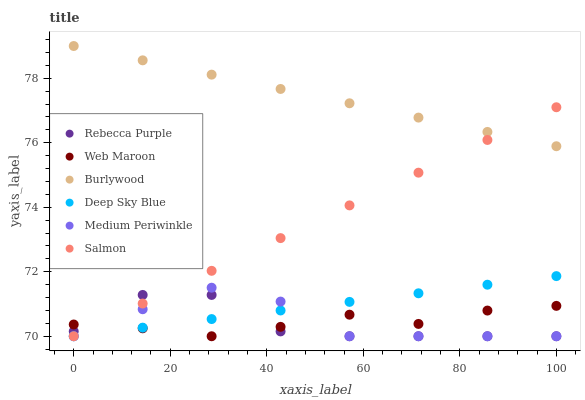Does Rebecca Purple have the minimum area under the curve?
Answer yes or no. Yes. Does Burlywood have the maximum area under the curve?
Answer yes or no. Yes. Does Web Maroon have the minimum area under the curve?
Answer yes or no. No. Does Web Maroon have the maximum area under the curve?
Answer yes or no. No. Is Burlywood the smoothest?
Answer yes or no. Yes. Is Rebecca Purple the roughest?
Answer yes or no. Yes. Is Web Maroon the smoothest?
Answer yes or no. No. Is Web Maroon the roughest?
Answer yes or no. No. Does Web Maroon have the lowest value?
Answer yes or no. Yes. Does Burlywood have the highest value?
Answer yes or no. Yes. Does Medium Periwinkle have the highest value?
Answer yes or no. No. Is Web Maroon less than Burlywood?
Answer yes or no. Yes. Is Burlywood greater than Rebecca Purple?
Answer yes or no. Yes. Does Deep Sky Blue intersect Web Maroon?
Answer yes or no. Yes. Is Deep Sky Blue less than Web Maroon?
Answer yes or no. No. Is Deep Sky Blue greater than Web Maroon?
Answer yes or no. No. Does Web Maroon intersect Burlywood?
Answer yes or no. No. 